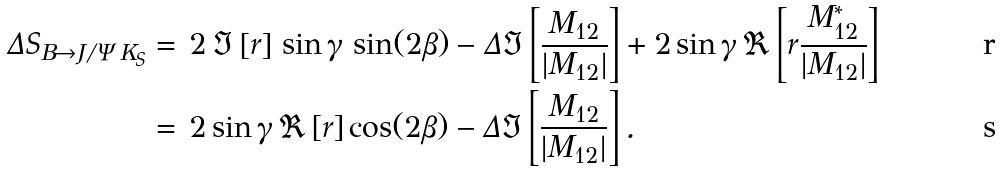<formula> <loc_0><loc_0><loc_500><loc_500>\Delta S _ { B \to J / \Psi \, K _ { S } } & = \, 2 \, \Im \left [ r \right ] \, \sin \gamma \, \sin ( 2 \beta ) - \Delta \Im \left [ \frac { M _ { 1 2 } } { | M _ { 1 2 } | } \right ] + 2 \sin \gamma \, \Re \left [ r \frac { M ^ { * } _ { 1 2 } } { | M _ { 1 2 } | } \right ] \\ & = \, 2 \sin \gamma \, \Re \left [ r \right ] \cos ( 2 \beta ) - \Delta \Im \left [ \frac { M _ { 1 2 } } { | M _ { 1 2 } | } \right ] .</formula> 